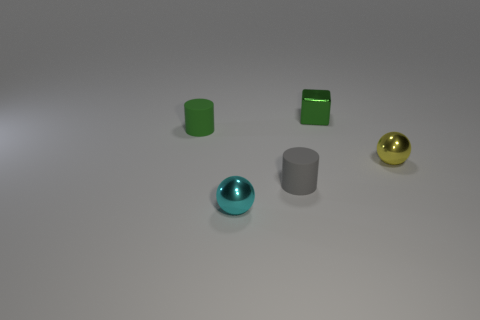Add 4 tiny green objects. How many objects exist? 9 Subtract all blocks. How many objects are left? 4 Add 1 green cylinders. How many green cylinders are left? 2 Add 2 gray rubber objects. How many gray rubber objects exist? 3 Subtract 0 red balls. How many objects are left? 5 Subtract all yellow balls. Subtract all cyan balls. How many objects are left? 3 